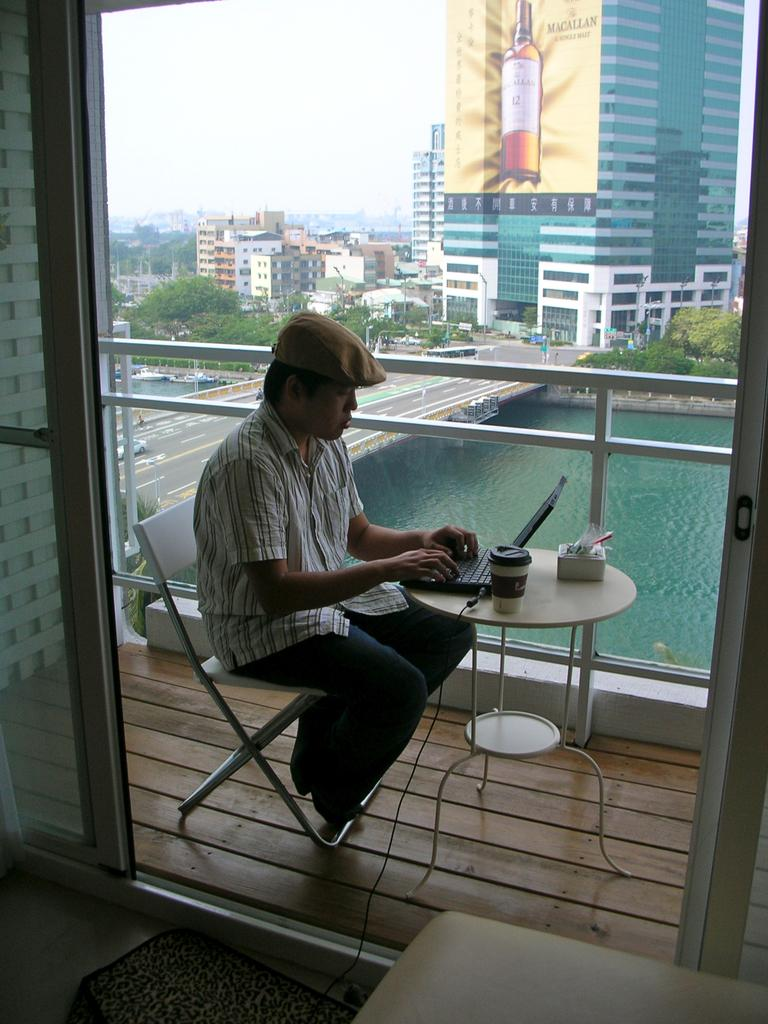What is the person in the image doing? The person is sitting on a chair and operating a laptop. What can be seen in the background of the image? There is water, a road, and buildings visible in the background. Can you describe the person's activity in more detail? The person is likely working or browsing the internet on the laptop. What color is the crayon being used by the person in the image? There is no crayon present in the image; the person is operating a laptop. How many locks can be seen on the laptop in the image? There are no locks visible on the laptop in the image. 